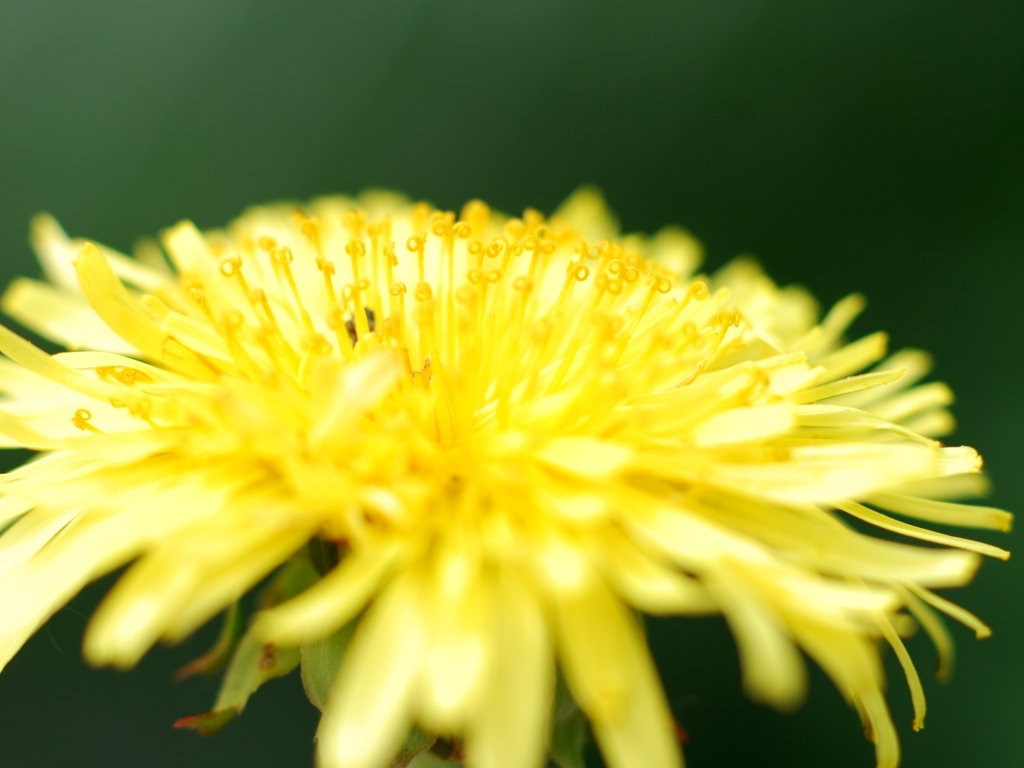What type of flower is shown in this image? The image shows a close-up of a dandelion flower, characterized by its bright yellow color and numerous tiny, tubular petals that are actually composite flower heads consisting of many smaller florets. 